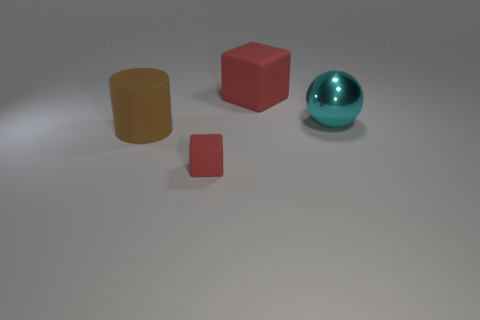Add 2 big red balls. How many objects exist? 6 Subtract all balls. How many objects are left? 3 Subtract 0 yellow cylinders. How many objects are left? 4 Subtract all big cyan things. Subtract all large metallic things. How many objects are left? 2 Add 2 cyan spheres. How many cyan spheres are left? 3 Add 1 gray shiny objects. How many gray shiny objects exist? 1 